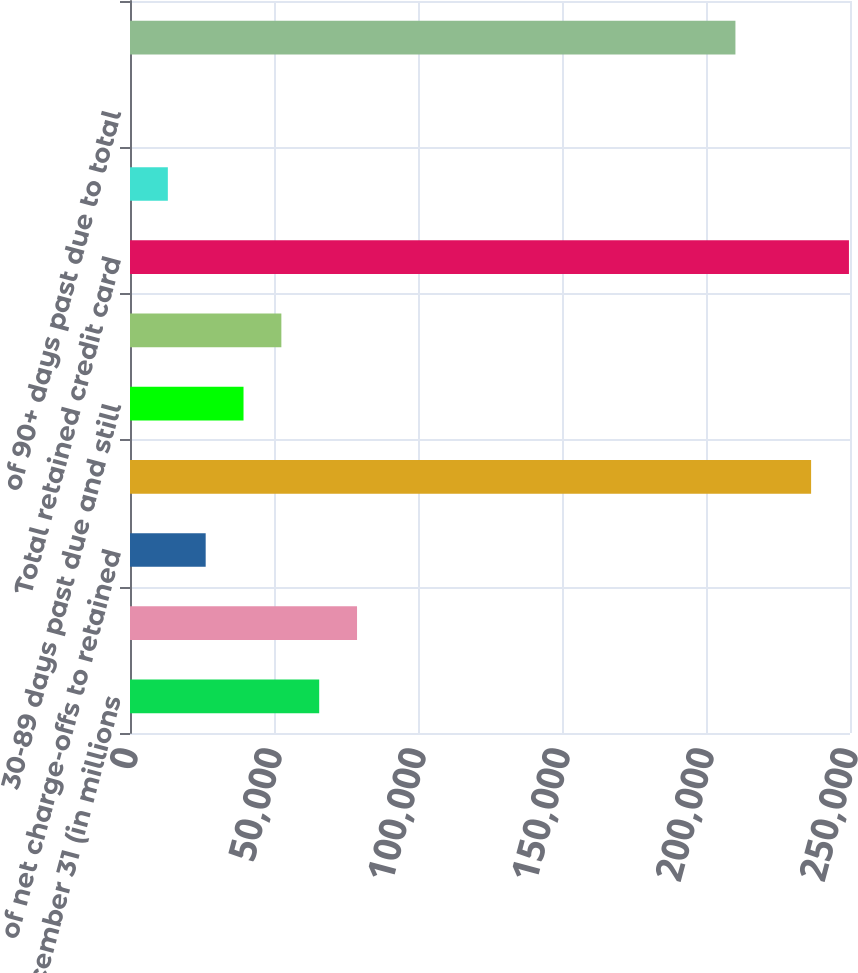Convert chart. <chart><loc_0><loc_0><loc_500><loc_500><bar_chart><fcel>ended December 31 (in millions<fcel>Net charge-offs<fcel>of net charge-offs to retained<fcel>Current and less than 30 days<fcel>30-89 days past due and still<fcel>90 or more days past due and<fcel>Total retained credit card<fcel>of 30+ days past due to total<fcel>of 90+ days past due to total<fcel>California<nl><fcel>65693.9<fcel>78832.5<fcel>26278<fcel>236496<fcel>39416.6<fcel>52555.2<fcel>249635<fcel>13139.4<fcel>0.72<fcel>210219<nl></chart> 